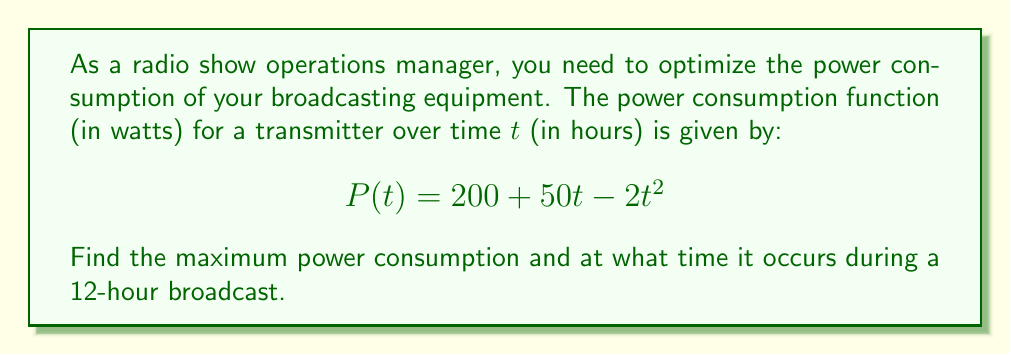Show me your answer to this math problem. To find the maximum power consumption and the time at which it occurs, we need to follow these steps:

1) First, we need to find the derivative of the power function $P(t)$:
   $$P'(t) = 50 - 4t$$

2) To find the critical points, set $P'(t) = 0$:
   $$50 - 4t = 0$$
   $$4t = 50$$
   $$t = \frac{50}{4} = 12.5$$

3) The critical point $t = 12.5$ is outside our domain of $[0, 12]$ hours. Therefore, we need to check the endpoints of our interval and the critical point within the interval.

4) Evaluate $P(t)$ at $t = 0$ and $t = 12$:
   $$P(0) = 200 + 50(0) - 2(0)^2 = 200$$
   $$P(12) = 200 + 50(12) - 2(12)^2 = 200 + 600 - 288 = 512$$

5) Since there are no critical points within the interval, the maximum must occur at one of the endpoints. Comparing the values:
   $$P(0) = 200 < P(12) = 512$$

6) Therefore, the maximum power consumption occurs at $t = 12$ hours and the maximum value is 512 watts.
Answer: Maximum power: 512 watts; Time: 12 hours 